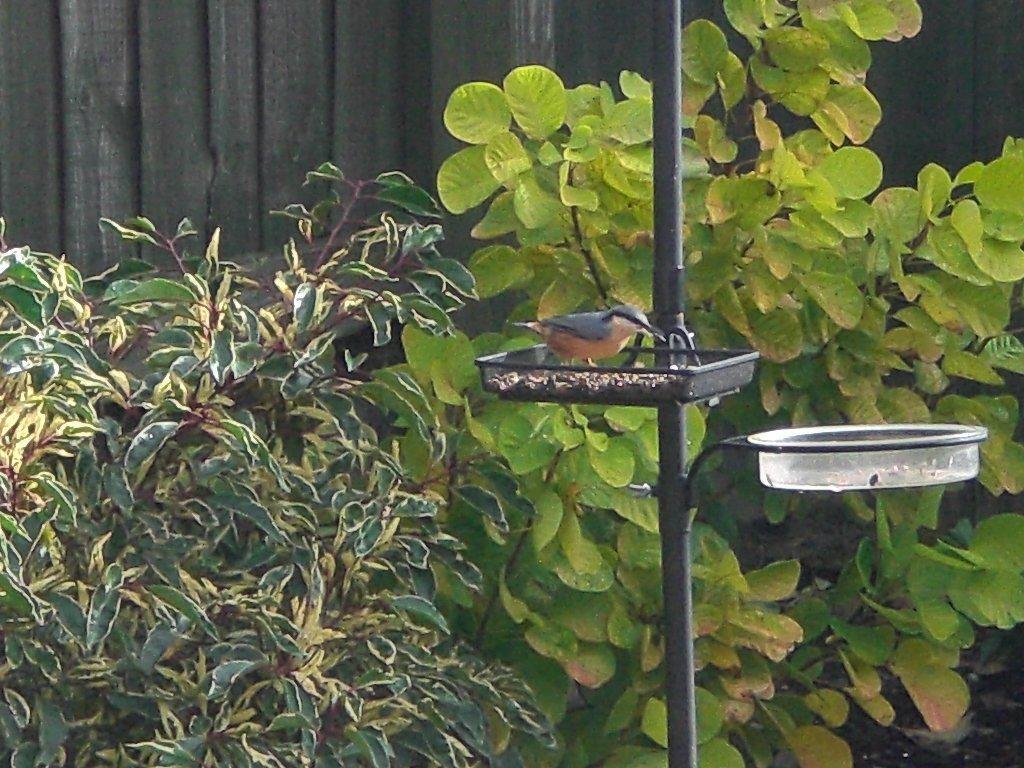Can you describe this image briefly? In the image there is a pole and there is a bird standing in a tray that is attached to the pole, behind that pole there are two plants and there is a wooden background behind the plants. 